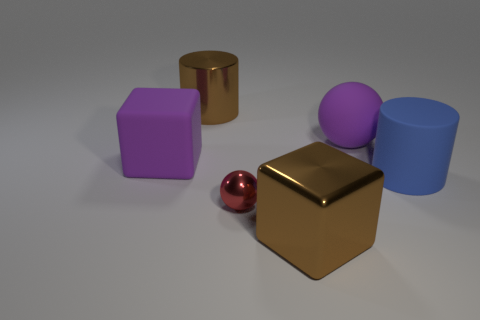Is there anything else that has the same size as the red shiny thing?
Give a very brief answer. No. There is a purple thing that is the same size as the matte cube; what is its shape?
Give a very brief answer. Sphere. Is the size of the brown metallic thing to the left of the big metallic cube the same as the cube behind the big blue thing?
Your answer should be compact. Yes. There is a large cylinder that is the same material as the large purple sphere; what color is it?
Offer a terse response. Blue. Do the brown object on the left side of the big brown shiny block and the brown thing that is in front of the purple sphere have the same material?
Provide a succinct answer. Yes. Are there any rubber things that have the same size as the metallic sphere?
Provide a succinct answer. No. What size is the brown object that is behind the cylinder that is on the right side of the tiny shiny object?
Ensure brevity in your answer.  Large. How many large blocks have the same color as the metallic cylinder?
Offer a terse response. 1. What is the shape of the large purple matte object that is on the left side of the big block on the right side of the big purple matte block?
Your answer should be compact. Cube. How many small blue things have the same material as the brown block?
Give a very brief answer. 0. 